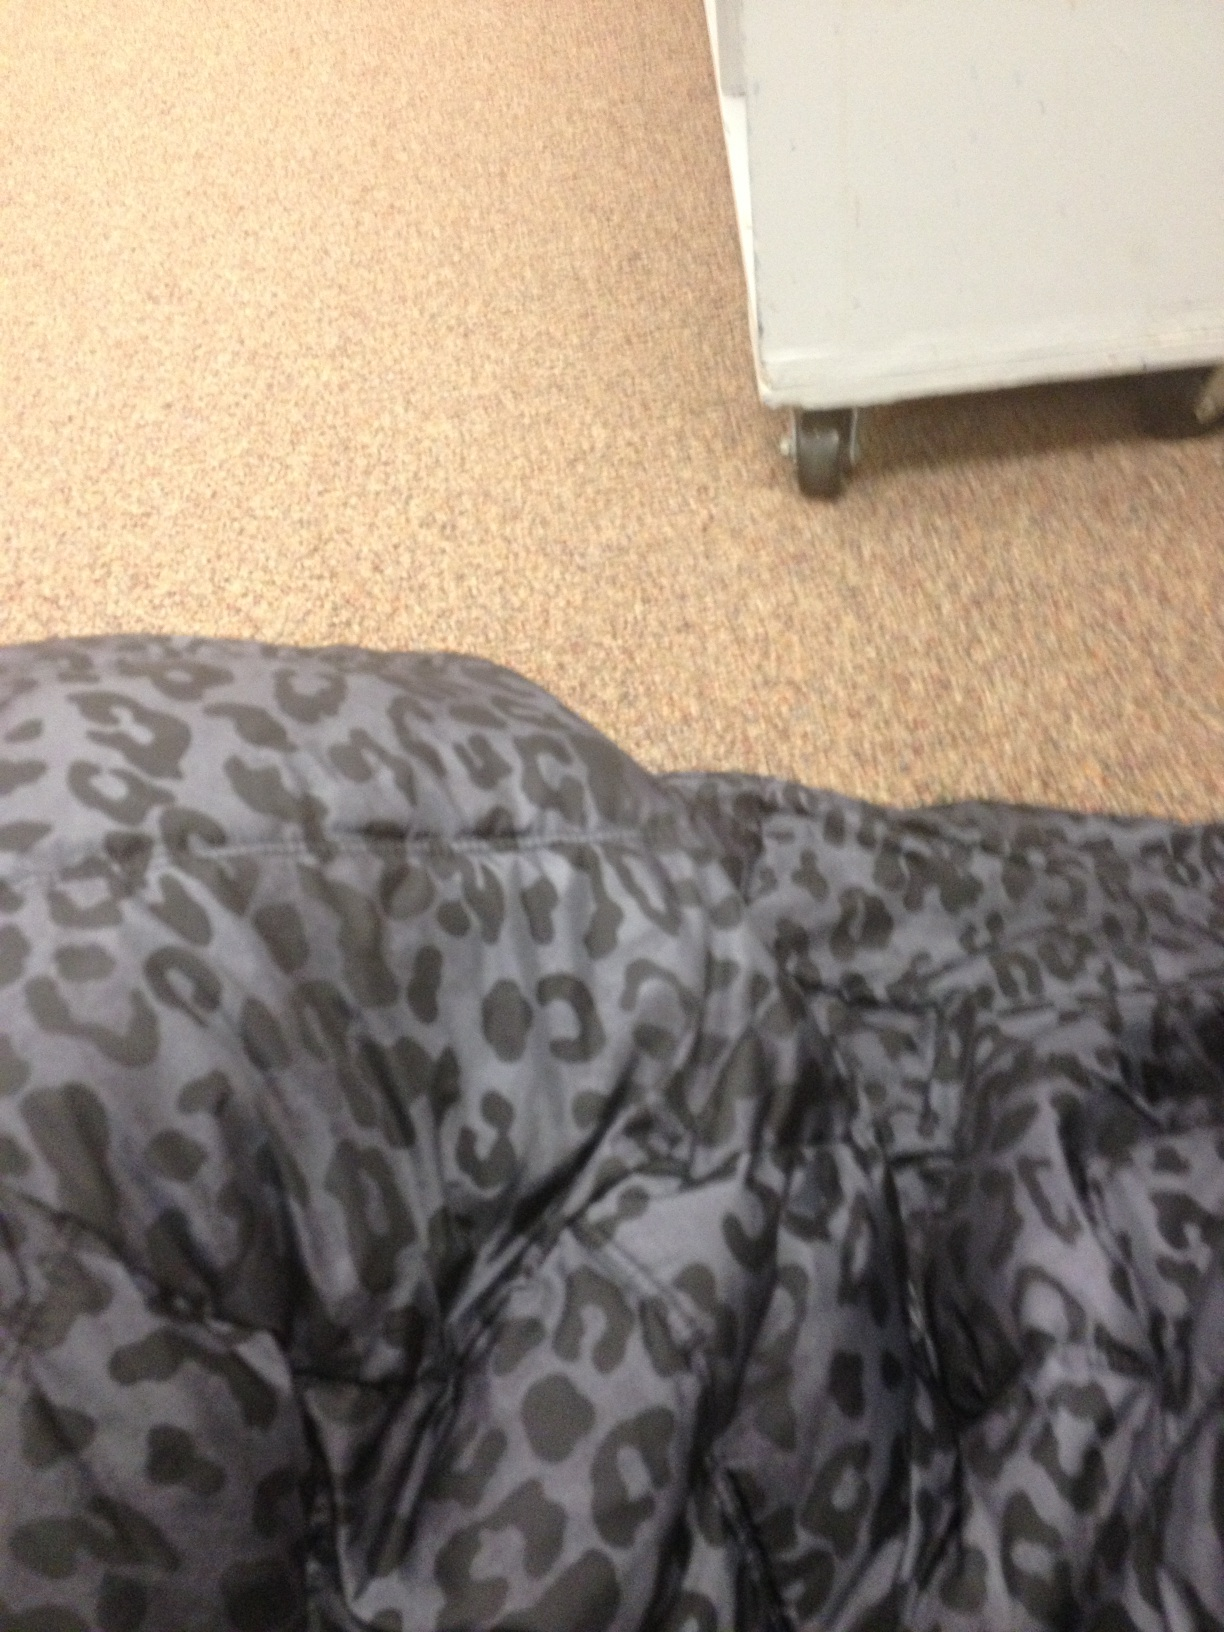What is this? from Vizwiz cheetah print 